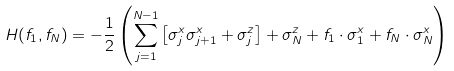<formula> <loc_0><loc_0><loc_500><loc_500>H ( f _ { 1 } , f _ { N } ) = - \frac { 1 } { 2 } \left ( \sum _ { j = 1 } ^ { N - 1 } \left [ \sigma ^ { x } _ { j } \sigma ^ { x } _ { j + 1 } + \sigma ^ { z } _ { j } \right ] + \sigma ^ { z } _ { N } + f _ { 1 } \cdot \sigma ^ { x } _ { 1 } + f _ { N } \cdot \sigma ^ { x } _ { N } \right )</formula> 